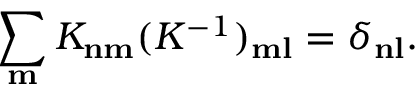Convert formula to latex. <formula><loc_0><loc_0><loc_500><loc_500>\sum _ { m } K _ { n m } ( K ^ { - 1 } ) _ { m l } = \delta _ { n l } .</formula> 